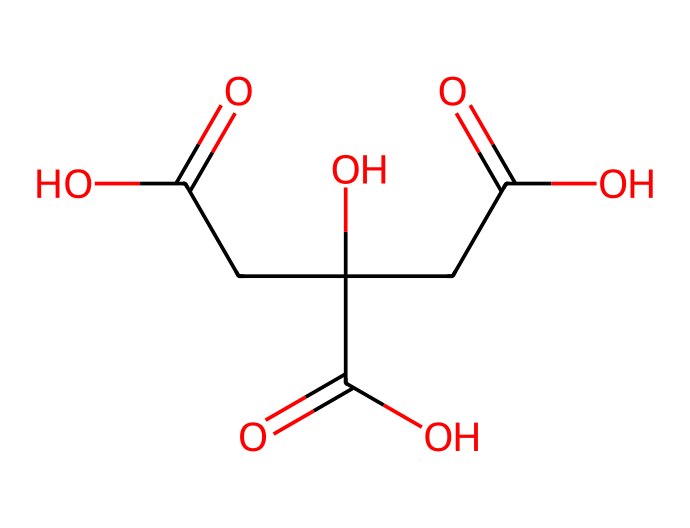What is the molecular formula of citric acid? The molecular formula is derived from the counts of each type of atom present in the structure. The SMILES indicates that citric acid contains 6 carbon (C) atoms, 8 hydrogen (H) atoms, and 7 oxygen (O) atoms, leading to the formula C6H8O7.
Answer: C6H8O7 How many carboxyl groups are present in citric acid? By examining the structure, we can identify the functional groups. Citric acid has three carboxyl (-COOH) groups, which are characterized by the presence of carbonyl (C=O) and hydroxyl (O-H) components linked to carbon atoms.
Answer: 3 What is the pH behavior of citric acid in solution? Citric acid is recognized as a weak acid that partially dissociates in water, resulting in a decrease in pH. This behavior is typical for weak acids.
Answer: weak acid Based on its structure, how many stereocenters does citric acid have? A stereocenter is usually defined as a carbon atom connected to four different groups. Upon inspecting the SMILES representation, there appears to be one carbon atom that meets this criterion, thus citric acid has one stereocenter in its structure.
Answer: 1 What functional groups are present in citric acid? Analyzing the structure, citric acid features multiple functional groups: three carboxylic acid groups (-COOH) and one hydroxyl group (-OH), which are pivotal in its acidity and solubility properties.
Answer: carboxylic acid and hydroxyl How does the presence of multiple carboxyl groups affect citric acid's acidity? The presence of multiple carboxylic acid groups in citric acid increases its acidity significantly. Each carboxyl group can donate a proton (H+), leading to a cumulative effect and enhancing its ability to lower the pH in solution compared to typical acids with fewer groups.
Answer: increases acidity What role does citric acid play in energy drinks? Citric acid is commonly utilized in energy drinks as a flavoring agent and preservative. Its tartness enhances the overall taste and contributes to the drink's acidity profile, which is desirable for consumer appeal.
Answer: flavoring agent and preservative 